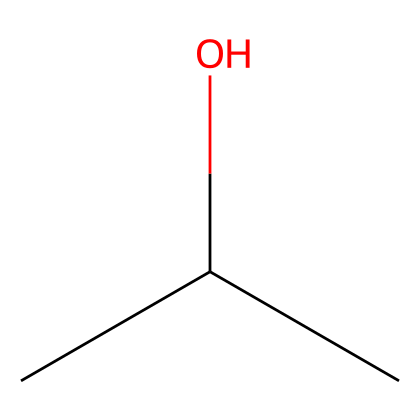What is the molecular formula of isopropyl alcohol? The SMILES representation indicates three carbon atoms (C), eight hydrogen atoms (H), and one oxygen atom (O). Therefore, the molecular formula can be derived as C3H8O.
Answer: C3H8O How many carbon atoms are present in isopropyl alcohol? By examining the SMILES notation, "CC(C)" shows a branched structure with three carbon (C) atoms.
Answer: 3 What type of functional group is present in isopropyl alcohol? The presence of the hydroxyl group (-OH) in the structure indicates that isopropyl alcohol contains an alcohol functional group.
Answer: alcohol Is isopropyl alcohol a polar or non-polar solvent? The hydroxyl group (-OH) creates a polar nature due to the electronegativity of oxygen compared to carbon and hydrogen, making isopropyl alcohol a polar solvent.
Answer: polar What is the primary use of isopropyl alcohol in art materials? Isopropyl alcohol is commonly used as a cleaning agent and solvent for thinning paint and cleaning brushes or tools used in mixed media artworks.
Answer: cleaning agent What is the boiling point range of isopropyl alcohol? The boiling point of isopropyl alcohol generally ranges from 82 to 83 degrees Celsius, which can be inferred from common data about this solvent’s properties.
Answer: 82-83 degrees Celsius Does isopropyl alcohol have any effects on oil-based paints? Isopropyl alcohol can effectively break down oil-based materials, making it useful for cleaning oil paints from equipment, tools, or surfaces.
Answer: effective 